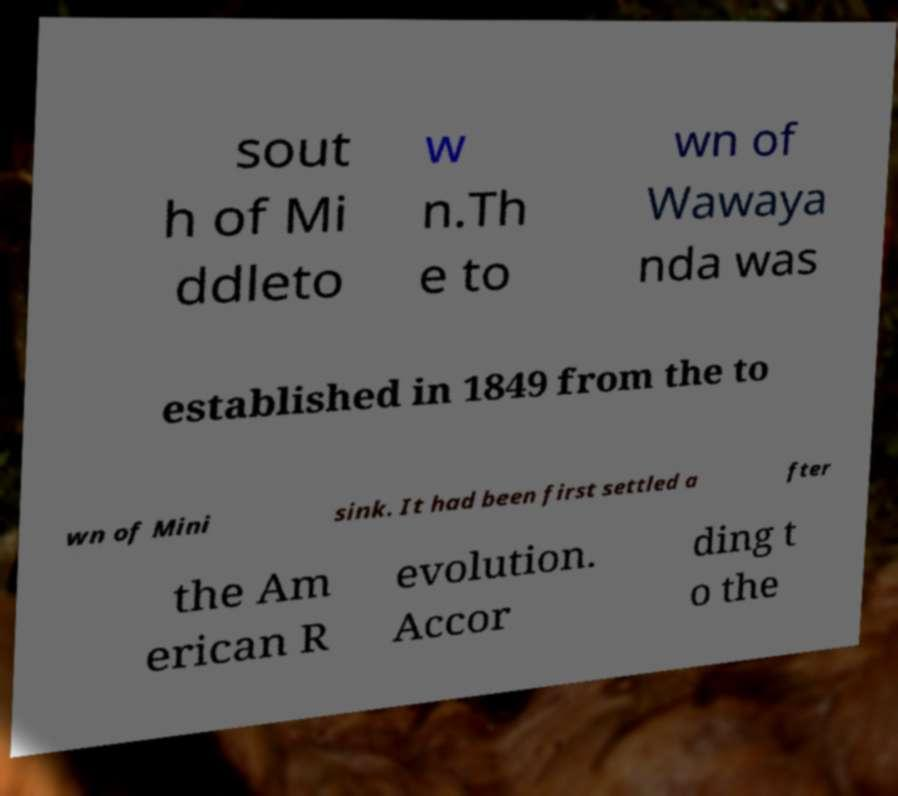Can you accurately transcribe the text from the provided image for me? sout h of Mi ddleto w n.Th e to wn of Wawaya nda was established in 1849 from the to wn of Mini sink. It had been first settled a fter the Am erican R evolution. Accor ding t o the 